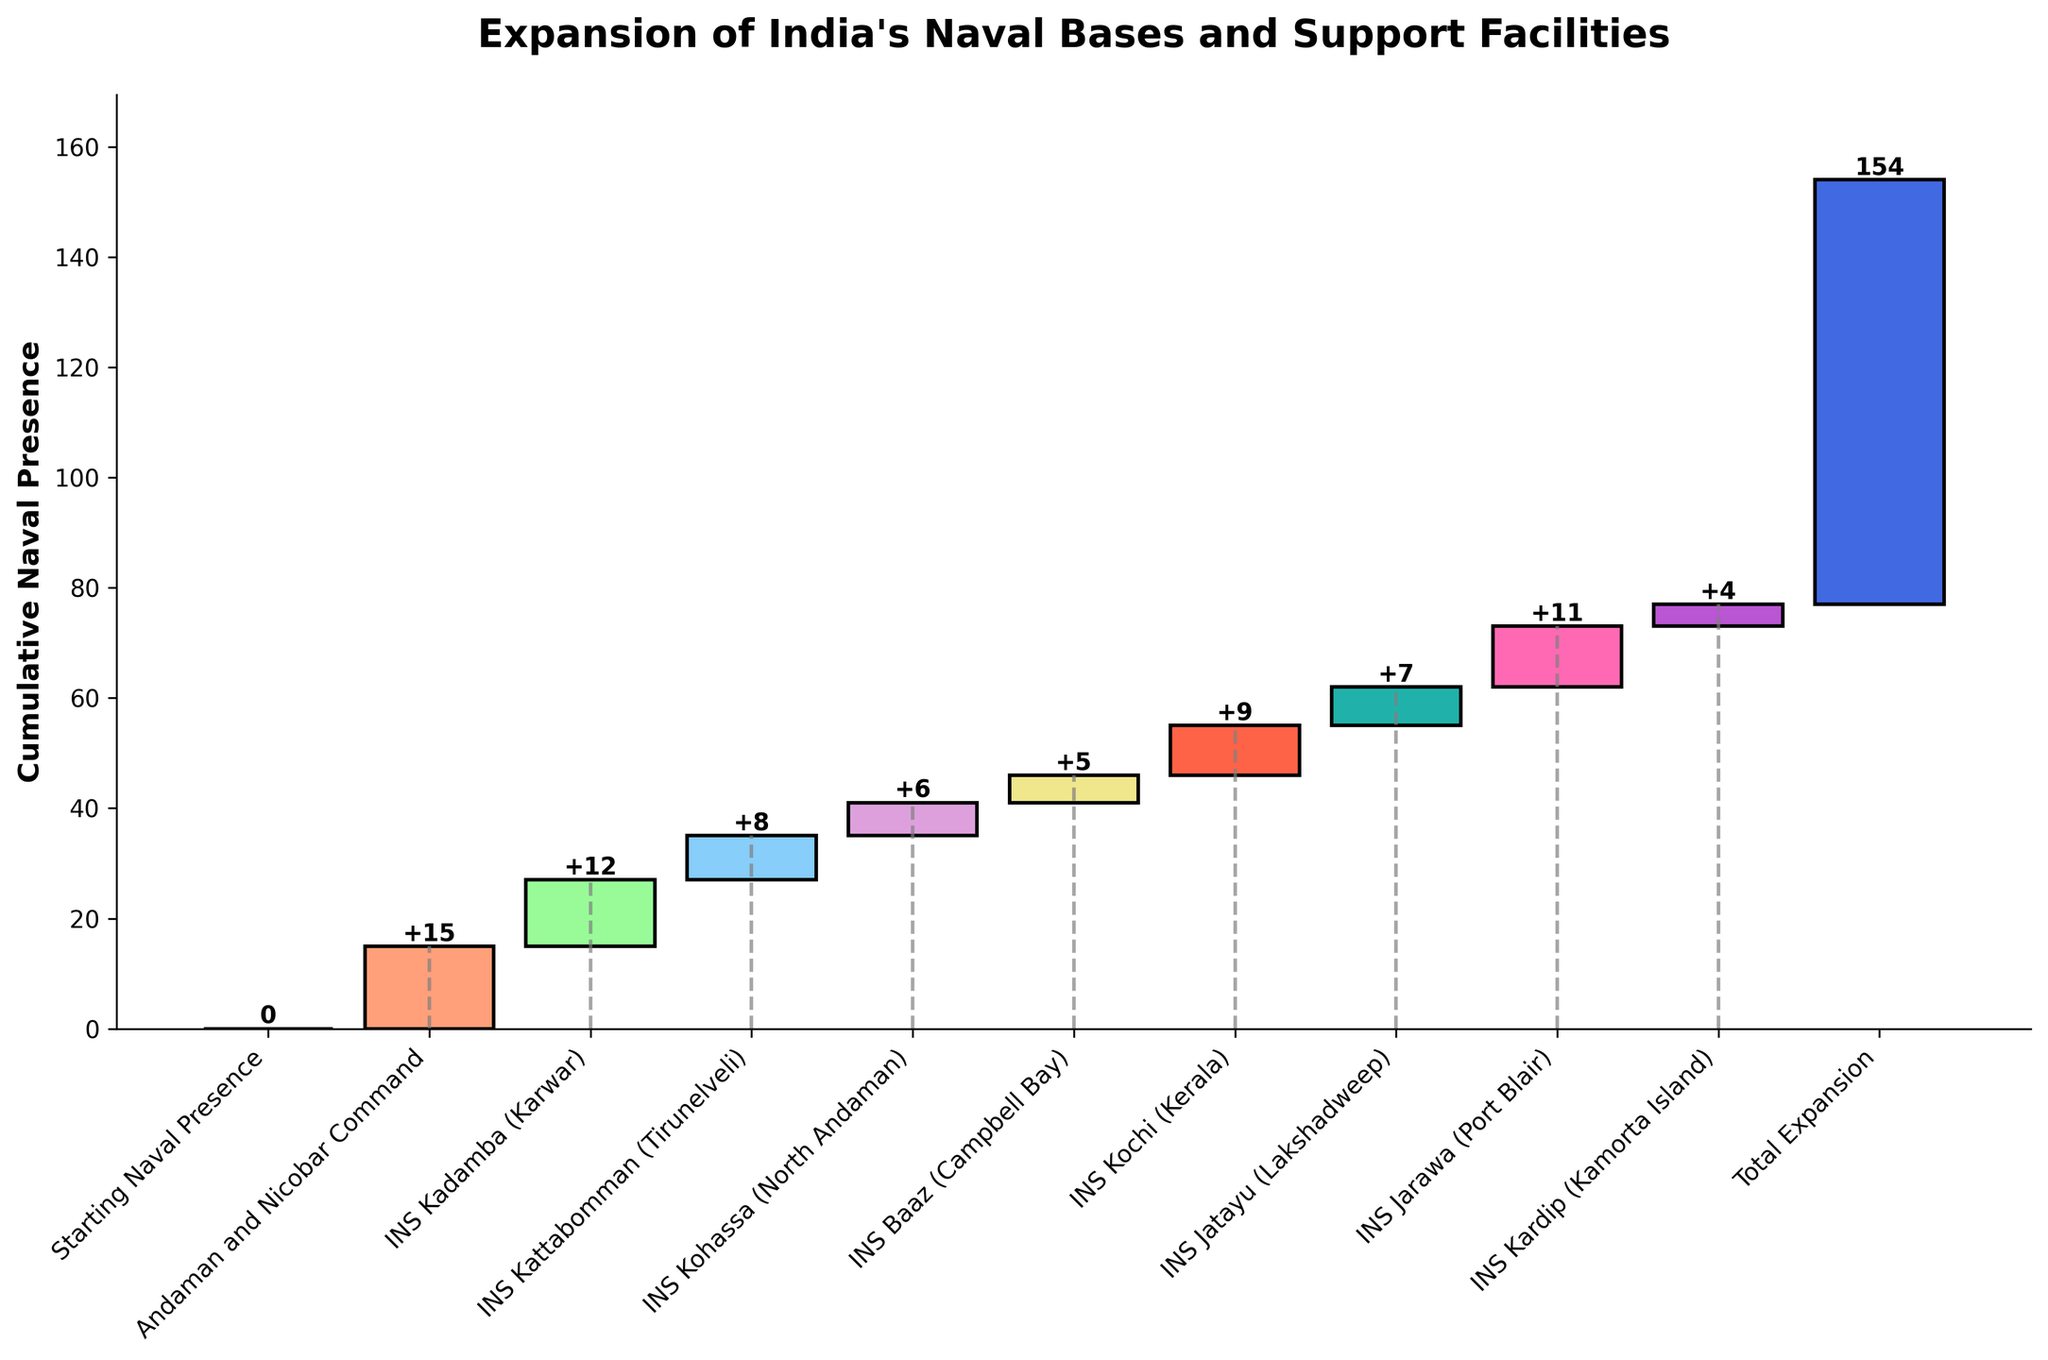What is the title of the chart? The title of the chart is given at the top and it summarizes the subject of the figure.
Answer: Expansion of India's Naval Bases and Support Facilities What is the cumulative naval presence at INS Kadamba (Karwar)? To find the cumulative presence at INS Kadamba, locate the point associated with INS Kadamba and check the text displayed directly above or on the bar.
Answer: 27 Which naval base shows the highest incremental increase in the chart? By looking at the heights of the individual bars, identify the one that stands out as the tallest. This corresponds with the base that contributes the largest increase.
Answer: Andaman and Nicobar Command What is the total expansion in naval presence according to the chart? The chart indicates the total increase in naval presence at the end of the chart. Look for the final cumulative total displayed.
Answer: 77 Compare the naval presence increments between INS Kochi (Kerala) and INS Kohassa (North Andaman). To compare the increments, examine the heights or the values displayed above the bars for both naval bases.
Answer: INS Kochi (9) has a higher increment than INS Kohassa (6) What is the combined incremental increase for INS Kadamba (Karwar) and INS Kochi (Kerala)? Add the values displayed above the bars for both INS Kadamba (Karwar) and INS Kochi (Kerala).
Answer: 21 How many naval bases had an incremental increase equal to or greater than 10? Count the number of bars with values equal to or exceeding 10.
Answer: 2 What is the cumulative increase after adding INS Jarawa (Port Blair)? Add the incremental increases up to and including INS Jarawa (Port Blair) to find the cumulative value.
Answer: 73 Which naval base has the smallest contribution to the total expansion? Identify the bar with the smallest height or the value that is the lowest among all the bases listed.
Answer: INS Kardip (Kamorta Island) What is the average incremental increase across all the naval bases listed (excluding the starting presence and total expansion)? Sum the values for all the naval bases listed and divide by the number of bases (excluding starting presence and total expansion).
Answer: 8.44 